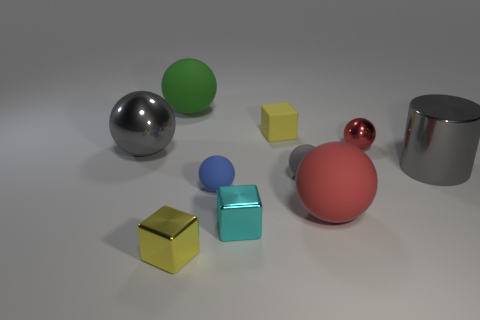What is the size of the gray cylinder that is made of the same material as the tiny cyan block?
Offer a very short reply. Large. What number of small shiny things have the same color as the rubber block?
Provide a succinct answer. 1. Is there a red matte object?
Keep it short and to the point. Yes. Does the green object have the same shape as the big gray shiny object that is to the left of the tiny rubber block?
Your answer should be compact. Yes. What is the color of the metal cylinder right of the metal sphere on the left side of the tiny rubber thing that is behind the big gray shiny cylinder?
Offer a terse response. Gray. Are there any gray shiny things right of the tiny cyan metallic object?
Your response must be concise. Yes. There is a metallic ball that is the same color as the metallic cylinder; what size is it?
Make the answer very short. Large. Is there a big blue sphere made of the same material as the small red object?
Offer a very short reply. No. What is the color of the small matte cube?
Offer a very short reply. Yellow. Is the shape of the yellow thing that is on the left side of the blue sphere the same as  the cyan object?
Make the answer very short. Yes. 